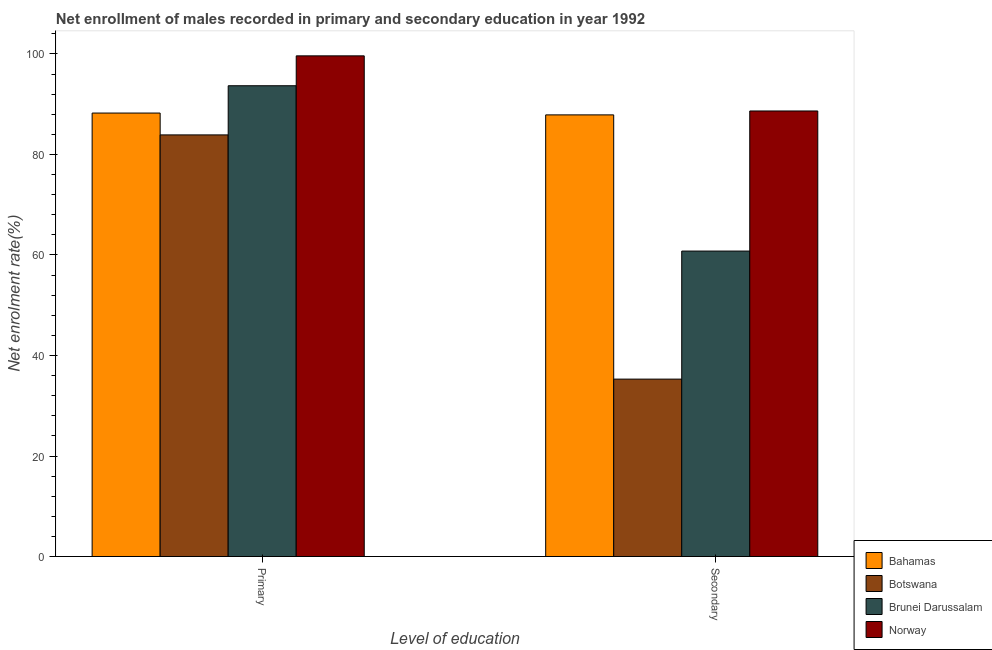How many groups of bars are there?
Ensure brevity in your answer.  2. How many bars are there on the 1st tick from the right?
Your answer should be very brief. 4. What is the label of the 2nd group of bars from the left?
Make the answer very short. Secondary. What is the enrollment rate in primary education in Botswana?
Ensure brevity in your answer.  83.89. Across all countries, what is the maximum enrollment rate in primary education?
Offer a terse response. 99.62. Across all countries, what is the minimum enrollment rate in primary education?
Offer a very short reply. 83.89. In which country was the enrollment rate in secondary education maximum?
Give a very brief answer. Norway. In which country was the enrollment rate in primary education minimum?
Give a very brief answer. Botswana. What is the total enrollment rate in secondary education in the graph?
Keep it short and to the point. 272.59. What is the difference between the enrollment rate in primary education in Botswana and that in Bahamas?
Give a very brief answer. -4.35. What is the difference between the enrollment rate in primary education in Botswana and the enrollment rate in secondary education in Bahamas?
Your response must be concise. -3.98. What is the average enrollment rate in secondary education per country?
Make the answer very short. 68.15. What is the difference between the enrollment rate in secondary education and enrollment rate in primary education in Norway?
Make the answer very short. -10.97. In how many countries, is the enrollment rate in secondary education greater than 64 %?
Ensure brevity in your answer.  2. What is the ratio of the enrollment rate in secondary education in Bahamas to that in Norway?
Ensure brevity in your answer.  0.99. Is the enrollment rate in secondary education in Bahamas less than that in Norway?
Offer a very short reply. Yes. In how many countries, is the enrollment rate in secondary education greater than the average enrollment rate in secondary education taken over all countries?
Ensure brevity in your answer.  2. What does the 2nd bar from the left in Secondary represents?
Keep it short and to the point. Botswana. What does the 3rd bar from the right in Primary represents?
Offer a terse response. Botswana. How many countries are there in the graph?
Keep it short and to the point. 4. Are the values on the major ticks of Y-axis written in scientific E-notation?
Your response must be concise. No. Does the graph contain any zero values?
Your answer should be compact. No. Where does the legend appear in the graph?
Provide a short and direct response. Bottom right. How many legend labels are there?
Make the answer very short. 4. How are the legend labels stacked?
Offer a very short reply. Vertical. What is the title of the graph?
Give a very brief answer. Net enrollment of males recorded in primary and secondary education in year 1992. Does "Switzerland" appear as one of the legend labels in the graph?
Offer a terse response. No. What is the label or title of the X-axis?
Provide a short and direct response. Level of education. What is the label or title of the Y-axis?
Ensure brevity in your answer.  Net enrolment rate(%). What is the Net enrolment rate(%) in Bahamas in Primary?
Your answer should be compact. 88.23. What is the Net enrolment rate(%) in Botswana in Primary?
Ensure brevity in your answer.  83.89. What is the Net enrolment rate(%) in Brunei Darussalam in Primary?
Keep it short and to the point. 93.67. What is the Net enrolment rate(%) of Norway in Primary?
Make the answer very short. 99.62. What is the Net enrolment rate(%) of Bahamas in Secondary?
Your answer should be very brief. 87.87. What is the Net enrolment rate(%) in Botswana in Secondary?
Ensure brevity in your answer.  35.3. What is the Net enrolment rate(%) of Brunei Darussalam in Secondary?
Your answer should be compact. 60.78. What is the Net enrolment rate(%) of Norway in Secondary?
Your response must be concise. 88.65. Across all Level of education, what is the maximum Net enrolment rate(%) in Bahamas?
Provide a succinct answer. 88.23. Across all Level of education, what is the maximum Net enrolment rate(%) in Botswana?
Keep it short and to the point. 83.89. Across all Level of education, what is the maximum Net enrolment rate(%) in Brunei Darussalam?
Keep it short and to the point. 93.67. Across all Level of education, what is the maximum Net enrolment rate(%) in Norway?
Your answer should be compact. 99.62. Across all Level of education, what is the minimum Net enrolment rate(%) in Bahamas?
Provide a succinct answer. 87.87. Across all Level of education, what is the minimum Net enrolment rate(%) of Botswana?
Ensure brevity in your answer.  35.3. Across all Level of education, what is the minimum Net enrolment rate(%) in Brunei Darussalam?
Your response must be concise. 60.78. Across all Level of education, what is the minimum Net enrolment rate(%) in Norway?
Your answer should be compact. 88.65. What is the total Net enrolment rate(%) of Bahamas in the graph?
Ensure brevity in your answer.  176.11. What is the total Net enrolment rate(%) of Botswana in the graph?
Offer a terse response. 119.19. What is the total Net enrolment rate(%) of Brunei Darussalam in the graph?
Keep it short and to the point. 154.45. What is the total Net enrolment rate(%) in Norway in the graph?
Your answer should be very brief. 188.27. What is the difference between the Net enrolment rate(%) of Bahamas in Primary and that in Secondary?
Give a very brief answer. 0.36. What is the difference between the Net enrolment rate(%) of Botswana in Primary and that in Secondary?
Your response must be concise. 48.59. What is the difference between the Net enrolment rate(%) in Brunei Darussalam in Primary and that in Secondary?
Give a very brief answer. 32.89. What is the difference between the Net enrolment rate(%) in Norway in Primary and that in Secondary?
Provide a short and direct response. 10.97. What is the difference between the Net enrolment rate(%) of Bahamas in Primary and the Net enrolment rate(%) of Botswana in Secondary?
Provide a succinct answer. 52.94. What is the difference between the Net enrolment rate(%) in Bahamas in Primary and the Net enrolment rate(%) in Brunei Darussalam in Secondary?
Offer a terse response. 27.46. What is the difference between the Net enrolment rate(%) of Bahamas in Primary and the Net enrolment rate(%) of Norway in Secondary?
Ensure brevity in your answer.  -0.41. What is the difference between the Net enrolment rate(%) of Botswana in Primary and the Net enrolment rate(%) of Brunei Darussalam in Secondary?
Give a very brief answer. 23.11. What is the difference between the Net enrolment rate(%) in Botswana in Primary and the Net enrolment rate(%) in Norway in Secondary?
Offer a very short reply. -4.76. What is the difference between the Net enrolment rate(%) in Brunei Darussalam in Primary and the Net enrolment rate(%) in Norway in Secondary?
Offer a very short reply. 5.02. What is the average Net enrolment rate(%) in Bahamas per Level of education?
Your response must be concise. 88.05. What is the average Net enrolment rate(%) in Botswana per Level of education?
Your response must be concise. 59.59. What is the average Net enrolment rate(%) in Brunei Darussalam per Level of education?
Provide a short and direct response. 77.22. What is the average Net enrolment rate(%) of Norway per Level of education?
Your answer should be compact. 94.13. What is the difference between the Net enrolment rate(%) of Bahamas and Net enrolment rate(%) of Botswana in Primary?
Offer a terse response. 4.35. What is the difference between the Net enrolment rate(%) of Bahamas and Net enrolment rate(%) of Brunei Darussalam in Primary?
Your answer should be very brief. -5.43. What is the difference between the Net enrolment rate(%) of Bahamas and Net enrolment rate(%) of Norway in Primary?
Give a very brief answer. -11.38. What is the difference between the Net enrolment rate(%) of Botswana and Net enrolment rate(%) of Brunei Darussalam in Primary?
Offer a very short reply. -9.78. What is the difference between the Net enrolment rate(%) of Botswana and Net enrolment rate(%) of Norway in Primary?
Provide a succinct answer. -15.73. What is the difference between the Net enrolment rate(%) of Brunei Darussalam and Net enrolment rate(%) of Norway in Primary?
Offer a very short reply. -5.95. What is the difference between the Net enrolment rate(%) in Bahamas and Net enrolment rate(%) in Botswana in Secondary?
Provide a short and direct response. 52.57. What is the difference between the Net enrolment rate(%) of Bahamas and Net enrolment rate(%) of Brunei Darussalam in Secondary?
Make the answer very short. 27.09. What is the difference between the Net enrolment rate(%) in Bahamas and Net enrolment rate(%) in Norway in Secondary?
Give a very brief answer. -0.78. What is the difference between the Net enrolment rate(%) of Botswana and Net enrolment rate(%) of Brunei Darussalam in Secondary?
Make the answer very short. -25.48. What is the difference between the Net enrolment rate(%) of Botswana and Net enrolment rate(%) of Norway in Secondary?
Ensure brevity in your answer.  -53.35. What is the difference between the Net enrolment rate(%) of Brunei Darussalam and Net enrolment rate(%) of Norway in Secondary?
Make the answer very short. -27.87. What is the ratio of the Net enrolment rate(%) in Bahamas in Primary to that in Secondary?
Make the answer very short. 1. What is the ratio of the Net enrolment rate(%) in Botswana in Primary to that in Secondary?
Offer a terse response. 2.38. What is the ratio of the Net enrolment rate(%) in Brunei Darussalam in Primary to that in Secondary?
Keep it short and to the point. 1.54. What is the ratio of the Net enrolment rate(%) of Norway in Primary to that in Secondary?
Make the answer very short. 1.12. What is the difference between the highest and the second highest Net enrolment rate(%) of Bahamas?
Your answer should be compact. 0.36. What is the difference between the highest and the second highest Net enrolment rate(%) in Botswana?
Make the answer very short. 48.59. What is the difference between the highest and the second highest Net enrolment rate(%) of Brunei Darussalam?
Provide a short and direct response. 32.89. What is the difference between the highest and the second highest Net enrolment rate(%) of Norway?
Offer a terse response. 10.97. What is the difference between the highest and the lowest Net enrolment rate(%) in Bahamas?
Offer a very short reply. 0.36. What is the difference between the highest and the lowest Net enrolment rate(%) in Botswana?
Offer a very short reply. 48.59. What is the difference between the highest and the lowest Net enrolment rate(%) in Brunei Darussalam?
Make the answer very short. 32.89. What is the difference between the highest and the lowest Net enrolment rate(%) in Norway?
Your answer should be very brief. 10.97. 